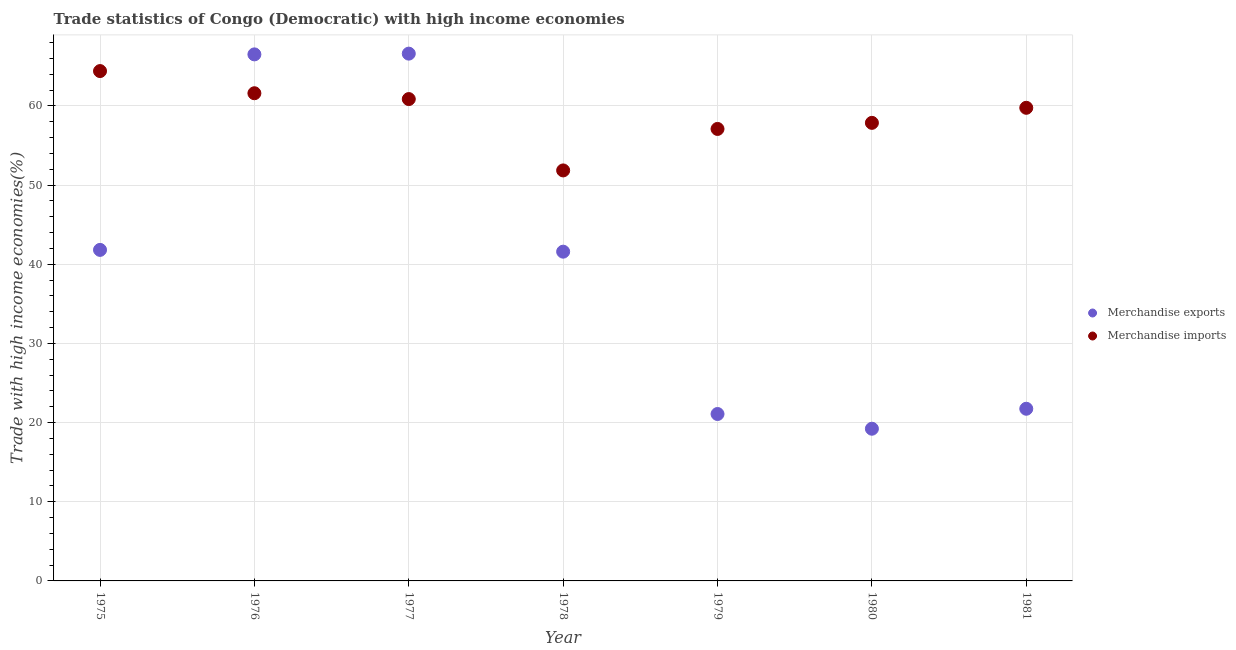What is the merchandise exports in 1976?
Give a very brief answer. 66.51. Across all years, what is the maximum merchandise imports?
Offer a very short reply. 64.4. Across all years, what is the minimum merchandise exports?
Offer a terse response. 19.22. In which year was the merchandise imports minimum?
Give a very brief answer. 1978. What is the total merchandise imports in the graph?
Offer a very short reply. 413.41. What is the difference between the merchandise exports in 1980 and that in 1981?
Provide a short and direct response. -2.52. What is the difference between the merchandise imports in 1979 and the merchandise exports in 1980?
Give a very brief answer. 37.87. What is the average merchandise imports per year?
Your response must be concise. 59.06. In the year 1979, what is the difference between the merchandise exports and merchandise imports?
Your answer should be very brief. -36.01. In how many years, is the merchandise exports greater than 2 %?
Your answer should be very brief. 7. What is the ratio of the merchandise exports in 1978 to that in 1980?
Your response must be concise. 2.16. Is the merchandise imports in 1977 less than that in 1979?
Offer a terse response. No. What is the difference between the highest and the second highest merchandise imports?
Provide a short and direct response. 2.8. What is the difference between the highest and the lowest merchandise exports?
Your response must be concise. 47.38. Is the sum of the merchandise exports in 1976 and 1979 greater than the maximum merchandise imports across all years?
Ensure brevity in your answer.  Yes. Does the merchandise exports monotonically increase over the years?
Give a very brief answer. No. Is the merchandise imports strictly greater than the merchandise exports over the years?
Keep it short and to the point. No. How many dotlines are there?
Keep it short and to the point. 2. What is the difference between two consecutive major ticks on the Y-axis?
Give a very brief answer. 10. Does the graph contain any zero values?
Keep it short and to the point. No. Does the graph contain grids?
Provide a short and direct response. Yes. Where does the legend appear in the graph?
Offer a very short reply. Center right. How many legend labels are there?
Provide a succinct answer. 2. What is the title of the graph?
Your answer should be compact. Trade statistics of Congo (Democratic) with high income economies. Does "constant 2005 US$" appear as one of the legend labels in the graph?
Ensure brevity in your answer.  No. What is the label or title of the Y-axis?
Offer a terse response. Trade with high income economies(%). What is the Trade with high income economies(%) of Merchandise exports in 1975?
Keep it short and to the point. 41.81. What is the Trade with high income economies(%) in Merchandise imports in 1975?
Provide a short and direct response. 64.4. What is the Trade with high income economies(%) of Merchandise exports in 1976?
Give a very brief answer. 66.51. What is the Trade with high income economies(%) of Merchandise imports in 1976?
Your answer should be very brief. 61.6. What is the Trade with high income economies(%) of Merchandise exports in 1977?
Make the answer very short. 66.6. What is the Trade with high income economies(%) in Merchandise imports in 1977?
Provide a short and direct response. 60.86. What is the Trade with high income economies(%) of Merchandise exports in 1978?
Keep it short and to the point. 41.59. What is the Trade with high income economies(%) of Merchandise imports in 1978?
Offer a terse response. 51.85. What is the Trade with high income economies(%) of Merchandise exports in 1979?
Keep it short and to the point. 21.08. What is the Trade with high income economies(%) in Merchandise imports in 1979?
Your answer should be very brief. 57.09. What is the Trade with high income economies(%) of Merchandise exports in 1980?
Your response must be concise. 19.22. What is the Trade with high income economies(%) in Merchandise imports in 1980?
Make the answer very short. 57.86. What is the Trade with high income economies(%) of Merchandise exports in 1981?
Your response must be concise. 21.75. What is the Trade with high income economies(%) of Merchandise imports in 1981?
Offer a very short reply. 59.76. Across all years, what is the maximum Trade with high income economies(%) in Merchandise exports?
Ensure brevity in your answer.  66.6. Across all years, what is the maximum Trade with high income economies(%) in Merchandise imports?
Ensure brevity in your answer.  64.4. Across all years, what is the minimum Trade with high income economies(%) in Merchandise exports?
Your response must be concise. 19.22. Across all years, what is the minimum Trade with high income economies(%) of Merchandise imports?
Your response must be concise. 51.85. What is the total Trade with high income economies(%) of Merchandise exports in the graph?
Provide a short and direct response. 278.56. What is the total Trade with high income economies(%) of Merchandise imports in the graph?
Offer a terse response. 413.41. What is the difference between the Trade with high income economies(%) of Merchandise exports in 1975 and that in 1976?
Your answer should be compact. -24.69. What is the difference between the Trade with high income economies(%) in Merchandise imports in 1975 and that in 1976?
Offer a very short reply. 2.8. What is the difference between the Trade with high income economies(%) in Merchandise exports in 1975 and that in 1977?
Your answer should be very brief. -24.79. What is the difference between the Trade with high income economies(%) in Merchandise imports in 1975 and that in 1977?
Your answer should be compact. 3.54. What is the difference between the Trade with high income economies(%) of Merchandise exports in 1975 and that in 1978?
Give a very brief answer. 0.22. What is the difference between the Trade with high income economies(%) in Merchandise imports in 1975 and that in 1978?
Offer a terse response. 12.55. What is the difference between the Trade with high income economies(%) of Merchandise exports in 1975 and that in 1979?
Your answer should be compact. 20.73. What is the difference between the Trade with high income economies(%) in Merchandise imports in 1975 and that in 1979?
Offer a terse response. 7.31. What is the difference between the Trade with high income economies(%) of Merchandise exports in 1975 and that in 1980?
Your response must be concise. 22.59. What is the difference between the Trade with high income economies(%) in Merchandise imports in 1975 and that in 1980?
Give a very brief answer. 6.54. What is the difference between the Trade with high income economies(%) of Merchandise exports in 1975 and that in 1981?
Your answer should be very brief. 20.07. What is the difference between the Trade with high income economies(%) in Merchandise imports in 1975 and that in 1981?
Offer a terse response. 4.64. What is the difference between the Trade with high income economies(%) of Merchandise exports in 1976 and that in 1977?
Make the answer very short. -0.09. What is the difference between the Trade with high income economies(%) of Merchandise imports in 1976 and that in 1977?
Your answer should be compact. 0.74. What is the difference between the Trade with high income economies(%) in Merchandise exports in 1976 and that in 1978?
Keep it short and to the point. 24.92. What is the difference between the Trade with high income economies(%) of Merchandise imports in 1976 and that in 1978?
Your answer should be very brief. 9.75. What is the difference between the Trade with high income economies(%) in Merchandise exports in 1976 and that in 1979?
Offer a terse response. 45.42. What is the difference between the Trade with high income economies(%) in Merchandise imports in 1976 and that in 1979?
Your answer should be compact. 4.51. What is the difference between the Trade with high income economies(%) in Merchandise exports in 1976 and that in 1980?
Offer a terse response. 47.28. What is the difference between the Trade with high income economies(%) of Merchandise imports in 1976 and that in 1980?
Give a very brief answer. 3.74. What is the difference between the Trade with high income economies(%) in Merchandise exports in 1976 and that in 1981?
Offer a terse response. 44.76. What is the difference between the Trade with high income economies(%) of Merchandise imports in 1976 and that in 1981?
Your answer should be compact. 1.84. What is the difference between the Trade with high income economies(%) in Merchandise exports in 1977 and that in 1978?
Ensure brevity in your answer.  25.01. What is the difference between the Trade with high income economies(%) in Merchandise imports in 1977 and that in 1978?
Your answer should be compact. 9.01. What is the difference between the Trade with high income economies(%) of Merchandise exports in 1977 and that in 1979?
Keep it short and to the point. 45.52. What is the difference between the Trade with high income economies(%) in Merchandise imports in 1977 and that in 1979?
Give a very brief answer. 3.77. What is the difference between the Trade with high income economies(%) of Merchandise exports in 1977 and that in 1980?
Your answer should be very brief. 47.38. What is the difference between the Trade with high income economies(%) in Merchandise imports in 1977 and that in 1980?
Provide a short and direct response. 3. What is the difference between the Trade with high income economies(%) in Merchandise exports in 1977 and that in 1981?
Ensure brevity in your answer.  44.86. What is the difference between the Trade with high income economies(%) of Merchandise imports in 1977 and that in 1981?
Provide a succinct answer. 1.1. What is the difference between the Trade with high income economies(%) in Merchandise exports in 1978 and that in 1979?
Make the answer very short. 20.5. What is the difference between the Trade with high income economies(%) of Merchandise imports in 1978 and that in 1979?
Your response must be concise. -5.24. What is the difference between the Trade with high income economies(%) of Merchandise exports in 1978 and that in 1980?
Offer a terse response. 22.36. What is the difference between the Trade with high income economies(%) of Merchandise imports in 1978 and that in 1980?
Offer a very short reply. -6.01. What is the difference between the Trade with high income economies(%) of Merchandise exports in 1978 and that in 1981?
Offer a very short reply. 19.84. What is the difference between the Trade with high income economies(%) of Merchandise imports in 1978 and that in 1981?
Give a very brief answer. -7.91. What is the difference between the Trade with high income economies(%) in Merchandise exports in 1979 and that in 1980?
Offer a terse response. 1.86. What is the difference between the Trade with high income economies(%) in Merchandise imports in 1979 and that in 1980?
Provide a succinct answer. -0.77. What is the difference between the Trade with high income economies(%) of Merchandise exports in 1979 and that in 1981?
Your answer should be very brief. -0.66. What is the difference between the Trade with high income economies(%) of Merchandise imports in 1979 and that in 1981?
Provide a short and direct response. -2.67. What is the difference between the Trade with high income economies(%) in Merchandise exports in 1980 and that in 1981?
Provide a short and direct response. -2.52. What is the difference between the Trade with high income economies(%) of Merchandise imports in 1980 and that in 1981?
Offer a very short reply. -1.9. What is the difference between the Trade with high income economies(%) in Merchandise exports in 1975 and the Trade with high income economies(%) in Merchandise imports in 1976?
Ensure brevity in your answer.  -19.79. What is the difference between the Trade with high income economies(%) of Merchandise exports in 1975 and the Trade with high income economies(%) of Merchandise imports in 1977?
Offer a very short reply. -19.05. What is the difference between the Trade with high income economies(%) of Merchandise exports in 1975 and the Trade with high income economies(%) of Merchandise imports in 1978?
Provide a short and direct response. -10.04. What is the difference between the Trade with high income economies(%) in Merchandise exports in 1975 and the Trade with high income economies(%) in Merchandise imports in 1979?
Offer a very short reply. -15.28. What is the difference between the Trade with high income economies(%) in Merchandise exports in 1975 and the Trade with high income economies(%) in Merchandise imports in 1980?
Offer a very short reply. -16.05. What is the difference between the Trade with high income economies(%) in Merchandise exports in 1975 and the Trade with high income economies(%) in Merchandise imports in 1981?
Ensure brevity in your answer.  -17.95. What is the difference between the Trade with high income economies(%) in Merchandise exports in 1976 and the Trade with high income economies(%) in Merchandise imports in 1977?
Your response must be concise. 5.64. What is the difference between the Trade with high income economies(%) of Merchandise exports in 1976 and the Trade with high income economies(%) of Merchandise imports in 1978?
Give a very brief answer. 14.66. What is the difference between the Trade with high income economies(%) in Merchandise exports in 1976 and the Trade with high income economies(%) in Merchandise imports in 1979?
Keep it short and to the point. 9.42. What is the difference between the Trade with high income economies(%) of Merchandise exports in 1976 and the Trade with high income economies(%) of Merchandise imports in 1980?
Ensure brevity in your answer.  8.65. What is the difference between the Trade with high income economies(%) in Merchandise exports in 1976 and the Trade with high income economies(%) in Merchandise imports in 1981?
Provide a succinct answer. 6.75. What is the difference between the Trade with high income economies(%) in Merchandise exports in 1977 and the Trade with high income economies(%) in Merchandise imports in 1978?
Your response must be concise. 14.75. What is the difference between the Trade with high income economies(%) in Merchandise exports in 1977 and the Trade with high income economies(%) in Merchandise imports in 1979?
Provide a short and direct response. 9.51. What is the difference between the Trade with high income economies(%) of Merchandise exports in 1977 and the Trade with high income economies(%) of Merchandise imports in 1980?
Make the answer very short. 8.74. What is the difference between the Trade with high income economies(%) in Merchandise exports in 1977 and the Trade with high income economies(%) in Merchandise imports in 1981?
Your answer should be very brief. 6.84. What is the difference between the Trade with high income economies(%) in Merchandise exports in 1978 and the Trade with high income economies(%) in Merchandise imports in 1979?
Your answer should be very brief. -15.5. What is the difference between the Trade with high income economies(%) of Merchandise exports in 1978 and the Trade with high income economies(%) of Merchandise imports in 1980?
Your response must be concise. -16.27. What is the difference between the Trade with high income economies(%) of Merchandise exports in 1978 and the Trade with high income economies(%) of Merchandise imports in 1981?
Your response must be concise. -18.17. What is the difference between the Trade with high income economies(%) in Merchandise exports in 1979 and the Trade with high income economies(%) in Merchandise imports in 1980?
Provide a succinct answer. -36.77. What is the difference between the Trade with high income economies(%) in Merchandise exports in 1979 and the Trade with high income economies(%) in Merchandise imports in 1981?
Your answer should be compact. -38.68. What is the difference between the Trade with high income economies(%) in Merchandise exports in 1980 and the Trade with high income economies(%) in Merchandise imports in 1981?
Your response must be concise. -40.54. What is the average Trade with high income economies(%) in Merchandise exports per year?
Make the answer very short. 39.79. What is the average Trade with high income economies(%) in Merchandise imports per year?
Your answer should be compact. 59.06. In the year 1975, what is the difference between the Trade with high income economies(%) of Merchandise exports and Trade with high income economies(%) of Merchandise imports?
Your response must be concise. -22.59. In the year 1976, what is the difference between the Trade with high income economies(%) of Merchandise exports and Trade with high income economies(%) of Merchandise imports?
Provide a short and direct response. 4.91. In the year 1977, what is the difference between the Trade with high income economies(%) in Merchandise exports and Trade with high income economies(%) in Merchandise imports?
Offer a very short reply. 5.74. In the year 1978, what is the difference between the Trade with high income economies(%) in Merchandise exports and Trade with high income economies(%) in Merchandise imports?
Your answer should be compact. -10.26. In the year 1979, what is the difference between the Trade with high income economies(%) in Merchandise exports and Trade with high income economies(%) in Merchandise imports?
Your answer should be very brief. -36.01. In the year 1980, what is the difference between the Trade with high income economies(%) in Merchandise exports and Trade with high income economies(%) in Merchandise imports?
Your response must be concise. -38.63. In the year 1981, what is the difference between the Trade with high income economies(%) in Merchandise exports and Trade with high income economies(%) in Merchandise imports?
Provide a succinct answer. -38.01. What is the ratio of the Trade with high income economies(%) of Merchandise exports in 1975 to that in 1976?
Give a very brief answer. 0.63. What is the ratio of the Trade with high income economies(%) of Merchandise imports in 1975 to that in 1976?
Give a very brief answer. 1.05. What is the ratio of the Trade with high income economies(%) of Merchandise exports in 1975 to that in 1977?
Your answer should be very brief. 0.63. What is the ratio of the Trade with high income economies(%) in Merchandise imports in 1975 to that in 1977?
Make the answer very short. 1.06. What is the ratio of the Trade with high income economies(%) of Merchandise exports in 1975 to that in 1978?
Make the answer very short. 1.01. What is the ratio of the Trade with high income economies(%) in Merchandise imports in 1975 to that in 1978?
Your answer should be very brief. 1.24. What is the ratio of the Trade with high income economies(%) in Merchandise exports in 1975 to that in 1979?
Keep it short and to the point. 1.98. What is the ratio of the Trade with high income economies(%) in Merchandise imports in 1975 to that in 1979?
Your answer should be very brief. 1.13. What is the ratio of the Trade with high income economies(%) in Merchandise exports in 1975 to that in 1980?
Offer a very short reply. 2.17. What is the ratio of the Trade with high income economies(%) in Merchandise imports in 1975 to that in 1980?
Provide a short and direct response. 1.11. What is the ratio of the Trade with high income economies(%) in Merchandise exports in 1975 to that in 1981?
Provide a succinct answer. 1.92. What is the ratio of the Trade with high income economies(%) in Merchandise imports in 1975 to that in 1981?
Give a very brief answer. 1.08. What is the ratio of the Trade with high income economies(%) of Merchandise exports in 1976 to that in 1977?
Offer a terse response. 1. What is the ratio of the Trade with high income economies(%) of Merchandise imports in 1976 to that in 1977?
Your answer should be very brief. 1.01. What is the ratio of the Trade with high income economies(%) of Merchandise exports in 1976 to that in 1978?
Your response must be concise. 1.6. What is the ratio of the Trade with high income economies(%) in Merchandise imports in 1976 to that in 1978?
Your response must be concise. 1.19. What is the ratio of the Trade with high income economies(%) of Merchandise exports in 1976 to that in 1979?
Ensure brevity in your answer.  3.15. What is the ratio of the Trade with high income economies(%) in Merchandise imports in 1976 to that in 1979?
Provide a short and direct response. 1.08. What is the ratio of the Trade with high income economies(%) in Merchandise exports in 1976 to that in 1980?
Your response must be concise. 3.46. What is the ratio of the Trade with high income economies(%) in Merchandise imports in 1976 to that in 1980?
Offer a very short reply. 1.06. What is the ratio of the Trade with high income economies(%) in Merchandise exports in 1976 to that in 1981?
Keep it short and to the point. 3.06. What is the ratio of the Trade with high income economies(%) of Merchandise imports in 1976 to that in 1981?
Your answer should be compact. 1.03. What is the ratio of the Trade with high income economies(%) in Merchandise exports in 1977 to that in 1978?
Ensure brevity in your answer.  1.6. What is the ratio of the Trade with high income economies(%) of Merchandise imports in 1977 to that in 1978?
Your answer should be compact. 1.17. What is the ratio of the Trade with high income economies(%) of Merchandise exports in 1977 to that in 1979?
Offer a terse response. 3.16. What is the ratio of the Trade with high income economies(%) in Merchandise imports in 1977 to that in 1979?
Your answer should be compact. 1.07. What is the ratio of the Trade with high income economies(%) in Merchandise exports in 1977 to that in 1980?
Offer a terse response. 3.46. What is the ratio of the Trade with high income economies(%) in Merchandise imports in 1977 to that in 1980?
Make the answer very short. 1.05. What is the ratio of the Trade with high income economies(%) in Merchandise exports in 1977 to that in 1981?
Your answer should be compact. 3.06. What is the ratio of the Trade with high income economies(%) in Merchandise imports in 1977 to that in 1981?
Provide a short and direct response. 1.02. What is the ratio of the Trade with high income economies(%) of Merchandise exports in 1978 to that in 1979?
Your answer should be very brief. 1.97. What is the ratio of the Trade with high income economies(%) in Merchandise imports in 1978 to that in 1979?
Your answer should be compact. 0.91. What is the ratio of the Trade with high income economies(%) of Merchandise exports in 1978 to that in 1980?
Your answer should be very brief. 2.16. What is the ratio of the Trade with high income economies(%) of Merchandise imports in 1978 to that in 1980?
Ensure brevity in your answer.  0.9. What is the ratio of the Trade with high income economies(%) in Merchandise exports in 1978 to that in 1981?
Keep it short and to the point. 1.91. What is the ratio of the Trade with high income economies(%) in Merchandise imports in 1978 to that in 1981?
Offer a very short reply. 0.87. What is the ratio of the Trade with high income economies(%) of Merchandise exports in 1979 to that in 1980?
Make the answer very short. 1.1. What is the ratio of the Trade with high income economies(%) of Merchandise imports in 1979 to that in 1980?
Keep it short and to the point. 0.99. What is the ratio of the Trade with high income economies(%) of Merchandise exports in 1979 to that in 1981?
Your answer should be compact. 0.97. What is the ratio of the Trade with high income economies(%) of Merchandise imports in 1979 to that in 1981?
Keep it short and to the point. 0.96. What is the ratio of the Trade with high income economies(%) of Merchandise exports in 1980 to that in 1981?
Make the answer very short. 0.88. What is the ratio of the Trade with high income economies(%) of Merchandise imports in 1980 to that in 1981?
Your response must be concise. 0.97. What is the difference between the highest and the second highest Trade with high income economies(%) of Merchandise exports?
Your answer should be compact. 0.09. What is the difference between the highest and the second highest Trade with high income economies(%) of Merchandise imports?
Provide a short and direct response. 2.8. What is the difference between the highest and the lowest Trade with high income economies(%) of Merchandise exports?
Keep it short and to the point. 47.38. What is the difference between the highest and the lowest Trade with high income economies(%) of Merchandise imports?
Offer a very short reply. 12.55. 